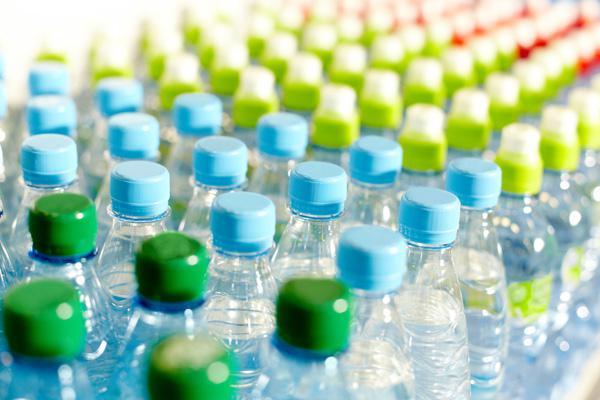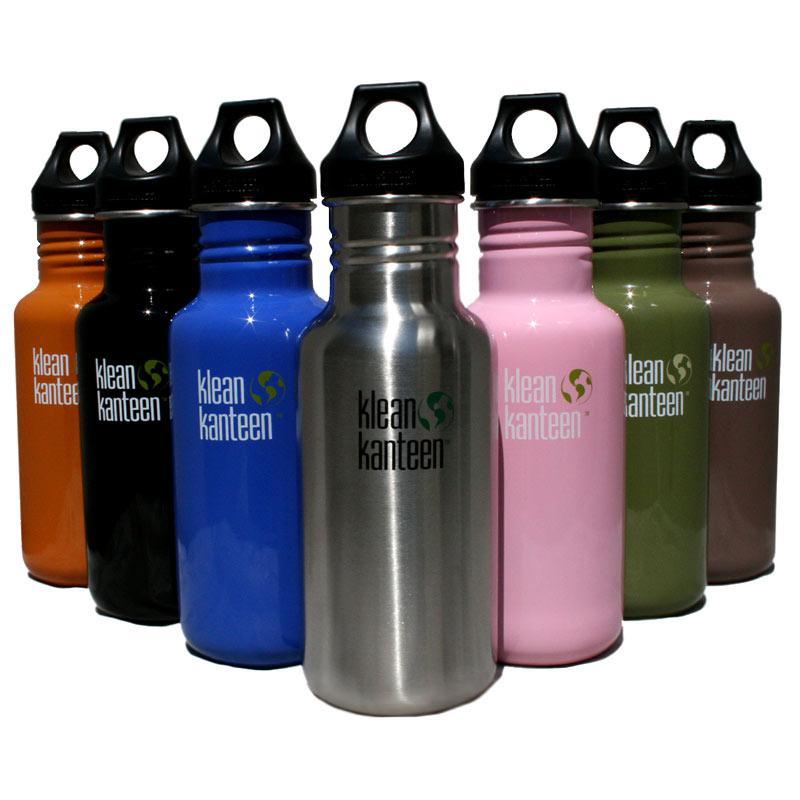The first image is the image on the left, the second image is the image on the right. For the images displayed, is the sentence "One image is of many rows of plastic water bottles with plastic caps." factually correct? Answer yes or no. Yes. The first image is the image on the left, the second image is the image on the right. Considering the images on both sides, is "The right image depicts refillable sport-type water bottles." valid? Answer yes or no. Yes. 